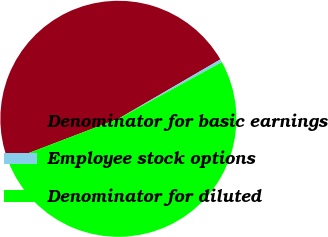Convert chart to OTSL. <chart><loc_0><loc_0><loc_500><loc_500><pie_chart><fcel>Denominator for basic earnings<fcel>Employee stock options<fcel>Denominator for diluted<nl><fcel>47.42%<fcel>0.41%<fcel>52.17%<nl></chart> 